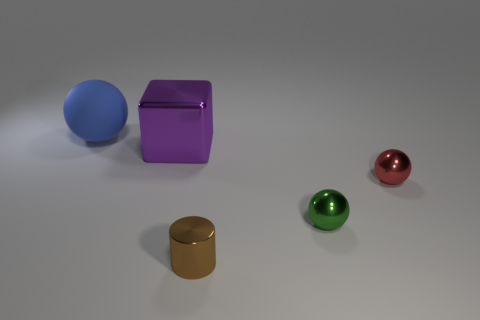Subtract all tiny balls. How many balls are left? 1 Add 4 small red objects. How many objects exist? 9 Subtract all cylinders. How many objects are left? 4 Subtract all tiny yellow matte cylinders. Subtract all big metal cubes. How many objects are left? 4 Add 5 tiny brown cylinders. How many tiny brown cylinders are left? 6 Add 3 small brown cylinders. How many small brown cylinders exist? 4 Subtract 0 gray cylinders. How many objects are left? 5 